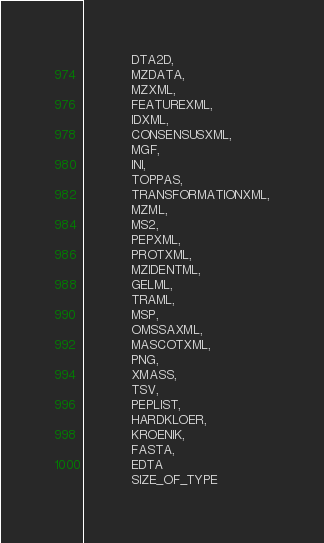<code> <loc_0><loc_0><loc_500><loc_500><_Cython_>            DTA2D,
            MZDATA,
            MZXML,
            FEATUREXML,
            IDXML,
            CONSENSUSXML,
            MGF,
            INI,
            TOPPAS,
            TRANSFORMATIONXML,
            MZML,
            MS2,
            PEPXML,
            PROTXML,
            MZIDENTML,
            GELML,
            TRAML,
            MSP,
            OMSSAXML,
            MASCOTXML,
            PNG,
            XMASS,
            TSV,
            PEPLIST,
            HARDKLOER,
            KROENIK,
            FASTA,
            EDTA
            SIZE_OF_TYPE
</code> 